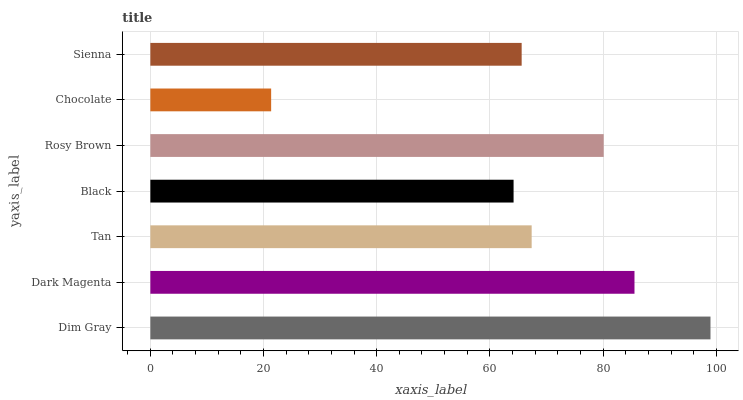Is Chocolate the minimum?
Answer yes or no. Yes. Is Dim Gray the maximum?
Answer yes or no. Yes. Is Dark Magenta the minimum?
Answer yes or no. No. Is Dark Magenta the maximum?
Answer yes or no. No. Is Dim Gray greater than Dark Magenta?
Answer yes or no. Yes. Is Dark Magenta less than Dim Gray?
Answer yes or no. Yes. Is Dark Magenta greater than Dim Gray?
Answer yes or no. No. Is Dim Gray less than Dark Magenta?
Answer yes or no. No. Is Tan the high median?
Answer yes or no. Yes. Is Tan the low median?
Answer yes or no. Yes. Is Rosy Brown the high median?
Answer yes or no. No. Is Sienna the low median?
Answer yes or no. No. 